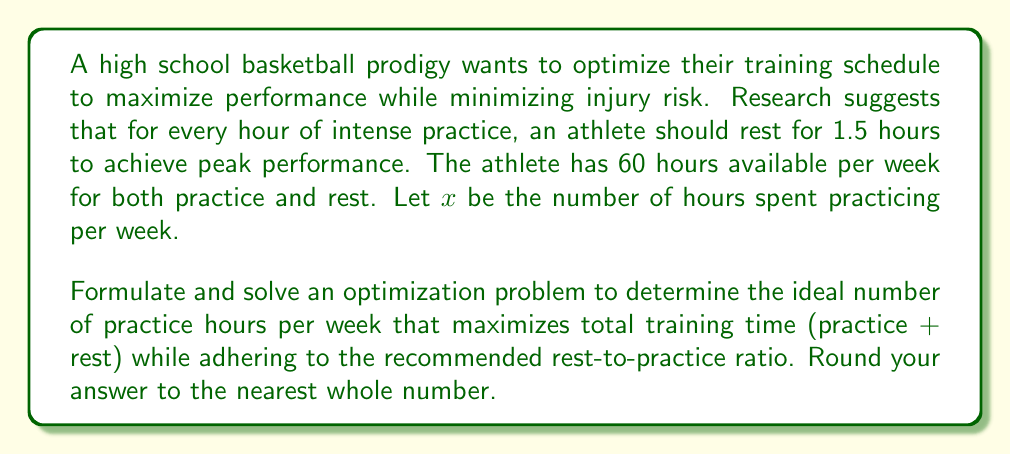Provide a solution to this math problem. Let's approach this step-by-step:

1) First, we need to set up our constraints:
   - Total time available: 60 hours
   - For every hour of practice, 1.5 hours of rest is needed

2) Let $x$ be the number of practice hours. Then, $1.5x$ represents the number of rest hours.

3) The total time spent on training (practice + rest) should not exceed 60 hours:
   $$ x + 1.5x \leq 60 $$

4) Simplify the inequality:
   $$ 2.5x \leq 60 $$

5) Solve for $x$:
   $$ x \leq 24 $$

6) To maximize total training time, we want to use all available 60 hours. So, we can set up an equation:
   $$ x + 1.5x = 60 $$

7) Solve this equation:
   $$ 2.5x = 60 $$
   $$ x = 24 $$

8) Check if this satisfies our constraint: 24 ≤ 24, which it does.

9) Therefore, the optimal solution is 24 hours of practice per week.

10) The corresponding rest time would be: $1.5 * 24 = 36$ hours per week.

11) Verify: 24 hours practice + 36 hours rest = 60 hours total, which matches our available time.
Answer: 24 hours of practice per week 